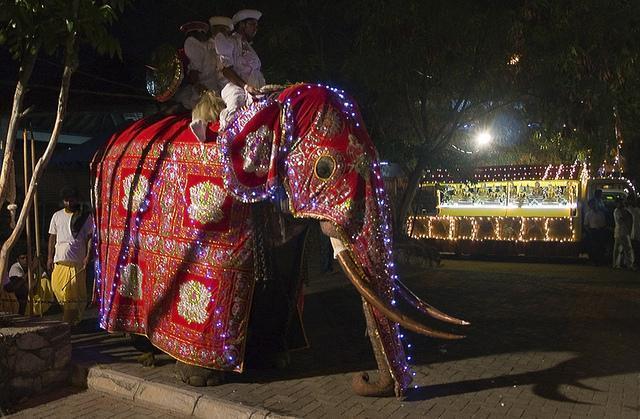How many elephants are in the photo?
Give a very brief answer. 1. How many people are there?
Give a very brief answer. 3. How many elephants can be seen?
Give a very brief answer. 1. 